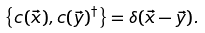Convert formula to latex. <formula><loc_0><loc_0><loc_500><loc_500>\left \{ c ( \vec { x } ) , c ( \vec { y } ) ^ { \dagger } \right \} = \delta ( \vec { x } - \vec { y } ) .</formula> 